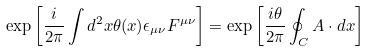<formula> <loc_0><loc_0><loc_500><loc_500>\exp \left [ \frac { i } { 2 \pi } \int d ^ { 2 } x \theta ( x ) \epsilon _ { \mu \nu } F ^ { \mu \nu } \right ] = \exp \left [ \frac { i \theta } { 2 \pi } \oint _ { C } A \cdot d x \right ]</formula> 